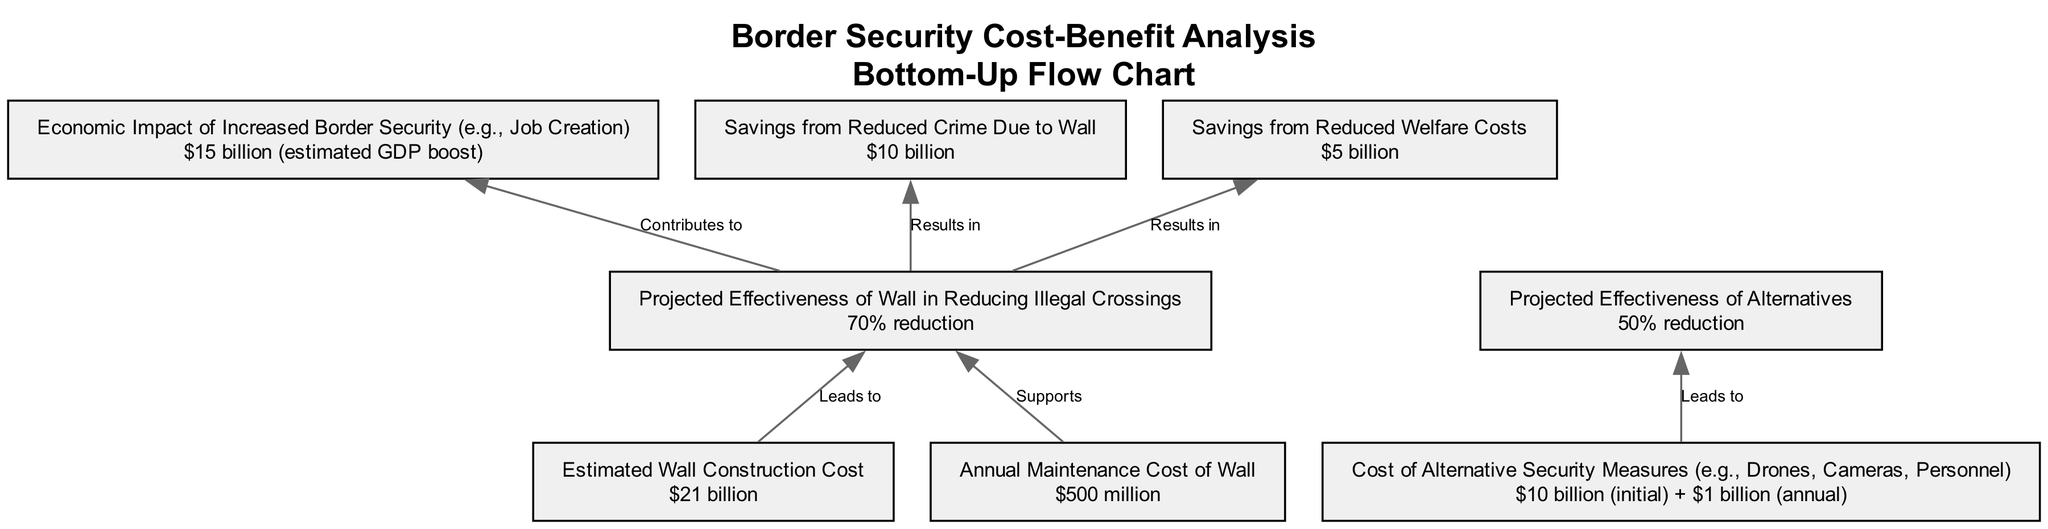What is the estimated wall construction cost? The node labeled "Estimated Wall Construction Cost" states the value is "$21 billion," which directly answers the question.
Answer: $21 billion What is the projected effectiveness of the wall in reducing illegal crossings? The node labeled "Projected Effectiveness of Wall in Reducing Illegal Crossings" shows a value of "70% reduction," directly providing the information required.
Answer: 70% reduction What is the annual maintenance cost of the wall? The node labeled "Annual Maintenance Cost of Wall" specifies the cost as "$500 million," giving the exact data requested.
Answer: $500 million What is the total cost of alternative security measures? The node "Cost of Alternative Security Measures" lists "$10 billion (initial) + $1 billion (annual)," which must be read as the total starting cost for initial setup.
Answer: $10 billion (initial) + $1 billion (annual) Which element contributes to economic impact through security effectiveness? The directed edge from "Projected Effectiveness of Wall in Reducing Illegal Crossings" to "Economic Impact of Increased Border Security" indicates that the wall's effectiveness directly contributes to economic impact.
Answer: Projected Effectiveness of Wall in Reducing Illegal Crossings How much can be saved from reduced crime due to the wall? The node "Savings from Reduced Crime Due to Wall" describes a saving of "$10 billion," showing the financial benefit from this aspect of border security.
Answer: $10 billion Which security measure has a higher projected effectiveness? By comparing the nodes, "Projected Effectiveness of Wall in Reducing Illegal Crossings" shows a 70% reduction while "Projected Effectiveness of Alternatives" shows a 50% reduction, indicating the wall is more effective.
Answer: Wall What is the total economic impact expected from increased border security? The "Economic Impact of Increased Border Security" node indicates an estimated GDP boost of "$15 billion," providing the information needed.
Answer: $15 billion What do the savings from reduced welfare costs amount to? The node labeled "Savings from Reduced Welfare Costs" states the figure as "$5 billion," directly answering the question.
Answer: $5 billion 